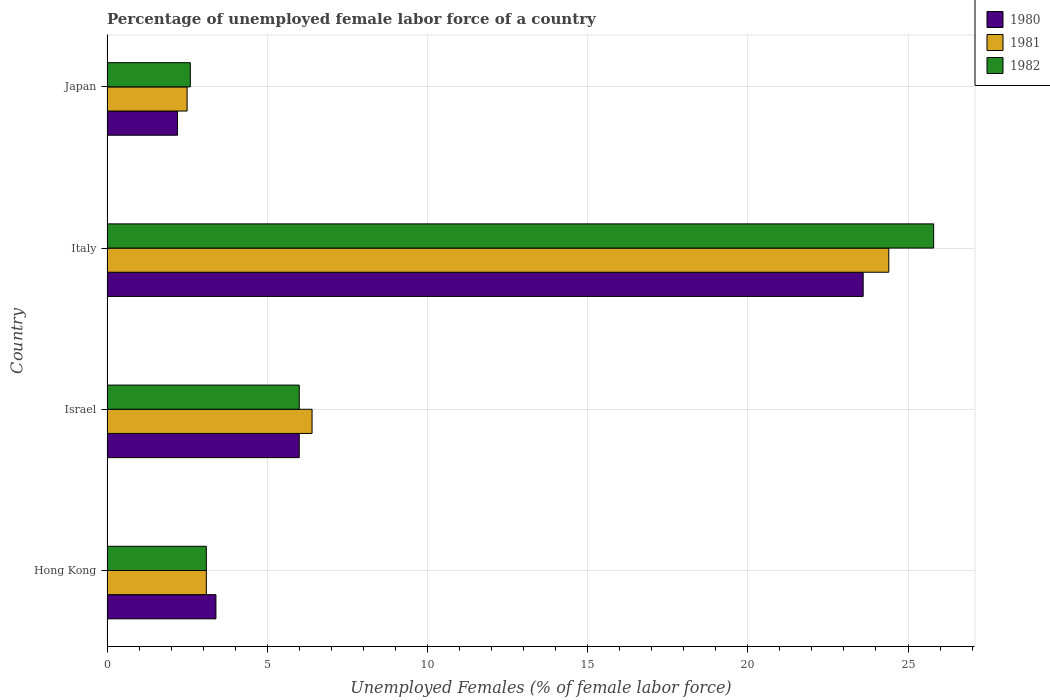How many different coloured bars are there?
Your answer should be very brief. 3. How many bars are there on the 1st tick from the top?
Provide a short and direct response. 3. What is the label of the 4th group of bars from the top?
Offer a very short reply. Hong Kong. What is the percentage of unemployed female labor force in 1982 in Japan?
Provide a short and direct response. 2.6. Across all countries, what is the maximum percentage of unemployed female labor force in 1982?
Your answer should be compact. 25.8. What is the total percentage of unemployed female labor force in 1981 in the graph?
Your answer should be very brief. 36.4. What is the difference between the percentage of unemployed female labor force in 1982 in Hong Kong and that in Italy?
Offer a terse response. -22.7. What is the difference between the percentage of unemployed female labor force in 1981 in Israel and the percentage of unemployed female labor force in 1980 in Japan?
Provide a short and direct response. 4.2. What is the average percentage of unemployed female labor force in 1980 per country?
Provide a succinct answer. 8.8. What is the difference between the percentage of unemployed female labor force in 1981 and percentage of unemployed female labor force in 1980 in Hong Kong?
Provide a succinct answer. -0.3. What is the ratio of the percentage of unemployed female labor force in 1981 in Hong Kong to that in Israel?
Keep it short and to the point. 0.48. What is the difference between the highest and the second highest percentage of unemployed female labor force in 1982?
Your answer should be compact. 19.8. What is the difference between the highest and the lowest percentage of unemployed female labor force in 1980?
Keep it short and to the point. 21.4. Is the sum of the percentage of unemployed female labor force in 1980 in Israel and Italy greater than the maximum percentage of unemployed female labor force in 1982 across all countries?
Give a very brief answer. Yes. What does the 3rd bar from the top in Hong Kong represents?
Provide a succinct answer. 1980. Is it the case that in every country, the sum of the percentage of unemployed female labor force in 1981 and percentage of unemployed female labor force in 1982 is greater than the percentage of unemployed female labor force in 1980?
Provide a succinct answer. Yes. How many bars are there?
Offer a very short reply. 12. How many countries are there in the graph?
Provide a short and direct response. 4. Does the graph contain any zero values?
Make the answer very short. No. Does the graph contain grids?
Provide a short and direct response. Yes. How are the legend labels stacked?
Your answer should be very brief. Vertical. What is the title of the graph?
Give a very brief answer. Percentage of unemployed female labor force of a country. Does "1998" appear as one of the legend labels in the graph?
Offer a terse response. No. What is the label or title of the X-axis?
Ensure brevity in your answer.  Unemployed Females (% of female labor force). What is the Unemployed Females (% of female labor force) in 1980 in Hong Kong?
Give a very brief answer. 3.4. What is the Unemployed Females (% of female labor force) of 1981 in Hong Kong?
Keep it short and to the point. 3.1. What is the Unemployed Females (% of female labor force) of 1982 in Hong Kong?
Your answer should be very brief. 3.1. What is the Unemployed Females (% of female labor force) of 1980 in Israel?
Your answer should be compact. 6. What is the Unemployed Females (% of female labor force) in 1981 in Israel?
Provide a succinct answer. 6.4. What is the Unemployed Females (% of female labor force) of 1980 in Italy?
Provide a short and direct response. 23.6. What is the Unemployed Females (% of female labor force) of 1981 in Italy?
Offer a terse response. 24.4. What is the Unemployed Females (% of female labor force) of 1982 in Italy?
Keep it short and to the point. 25.8. What is the Unemployed Females (% of female labor force) of 1980 in Japan?
Offer a terse response. 2.2. What is the Unemployed Females (% of female labor force) of 1982 in Japan?
Offer a terse response. 2.6. Across all countries, what is the maximum Unemployed Females (% of female labor force) of 1980?
Ensure brevity in your answer.  23.6. Across all countries, what is the maximum Unemployed Females (% of female labor force) of 1981?
Keep it short and to the point. 24.4. Across all countries, what is the maximum Unemployed Females (% of female labor force) of 1982?
Provide a short and direct response. 25.8. Across all countries, what is the minimum Unemployed Females (% of female labor force) in 1980?
Make the answer very short. 2.2. Across all countries, what is the minimum Unemployed Females (% of female labor force) in 1982?
Offer a very short reply. 2.6. What is the total Unemployed Females (% of female labor force) in 1980 in the graph?
Your answer should be very brief. 35.2. What is the total Unemployed Females (% of female labor force) of 1981 in the graph?
Provide a succinct answer. 36.4. What is the total Unemployed Females (% of female labor force) in 1982 in the graph?
Provide a short and direct response. 37.5. What is the difference between the Unemployed Females (% of female labor force) in 1980 in Hong Kong and that in Israel?
Give a very brief answer. -2.6. What is the difference between the Unemployed Females (% of female labor force) of 1982 in Hong Kong and that in Israel?
Your answer should be compact. -2.9. What is the difference between the Unemployed Females (% of female labor force) of 1980 in Hong Kong and that in Italy?
Provide a succinct answer. -20.2. What is the difference between the Unemployed Females (% of female labor force) of 1981 in Hong Kong and that in Italy?
Provide a succinct answer. -21.3. What is the difference between the Unemployed Females (% of female labor force) in 1982 in Hong Kong and that in Italy?
Ensure brevity in your answer.  -22.7. What is the difference between the Unemployed Females (% of female labor force) of 1980 in Israel and that in Italy?
Keep it short and to the point. -17.6. What is the difference between the Unemployed Females (% of female labor force) of 1982 in Israel and that in Italy?
Offer a very short reply. -19.8. What is the difference between the Unemployed Females (% of female labor force) in 1980 in Israel and that in Japan?
Offer a very short reply. 3.8. What is the difference between the Unemployed Females (% of female labor force) of 1980 in Italy and that in Japan?
Provide a succinct answer. 21.4. What is the difference between the Unemployed Females (% of female labor force) in 1981 in Italy and that in Japan?
Ensure brevity in your answer.  21.9. What is the difference between the Unemployed Females (% of female labor force) in 1982 in Italy and that in Japan?
Provide a short and direct response. 23.2. What is the difference between the Unemployed Females (% of female labor force) of 1980 in Hong Kong and the Unemployed Females (% of female labor force) of 1981 in Israel?
Your answer should be very brief. -3. What is the difference between the Unemployed Females (% of female labor force) of 1980 in Hong Kong and the Unemployed Females (% of female labor force) of 1982 in Israel?
Make the answer very short. -2.6. What is the difference between the Unemployed Females (% of female labor force) in 1980 in Hong Kong and the Unemployed Females (% of female labor force) in 1982 in Italy?
Make the answer very short. -22.4. What is the difference between the Unemployed Females (% of female labor force) in 1981 in Hong Kong and the Unemployed Females (% of female labor force) in 1982 in Italy?
Offer a terse response. -22.7. What is the difference between the Unemployed Females (% of female labor force) of 1980 in Hong Kong and the Unemployed Females (% of female labor force) of 1981 in Japan?
Your response must be concise. 0.9. What is the difference between the Unemployed Females (% of female labor force) in 1980 in Hong Kong and the Unemployed Females (% of female labor force) in 1982 in Japan?
Make the answer very short. 0.8. What is the difference between the Unemployed Females (% of female labor force) in 1981 in Hong Kong and the Unemployed Females (% of female labor force) in 1982 in Japan?
Offer a very short reply. 0.5. What is the difference between the Unemployed Females (% of female labor force) of 1980 in Israel and the Unemployed Females (% of female labor force) of 1981 in Italy?
Your answer should be compact. -18.4. What is the difference between the Unemployed Females (% of female labor force) of 1980 in Israel and the Unemployed Females (% of female labor force) of 1982 in Italy?
Make the answer very short. -19.8. What is the difference between the Unemployed Females (% of female labor force) of 1981 in Israel and the Unemployed Females (% of female labor force) of 1982 in Italy?
Ensure brevity in your answer.  -19.4. What is the difference between the Unemployed Females (% of female labor force) in 1981 in Israel and the Unemployed Females (% of female labor force) in 1982 in Japan?
Offer a terse response. 3.8. What is the difference between the Unemployed Females (% of female labor force) in 1980 in Italy and the Unemployed Females (% of female labor force) in 1981 in Japan?
Your response must be concise. 21.1. What is the difference between the Unemployed Females (% of female labor force) in 1980 in Italy and the Unemployed Females (% of female labor force) in 1982 in Japan?
Provide a succinct answer. 21. What is the difference between the Unemployed Females (% of female labor force) in 1981 in Italy and the Unemployed Females (% of female labor force) in 1982 in Japan?
Keep it short and to the point. 21.8. What is the average Unemployed Females (% of female labor force) of 1981 per country?
Your answer should be very brief. 9.1. What is the average Unemployed Females (% of female labor force) in 1982 per country?
Your answer should be compact. 9.38. What is the difference between the Unemployed Females (% of female labor force) in 1980 and Unemployed Females (% of female labor force) in 1981 in Israel?
Make the answer very short. -0.4. What is the difference between the Unemployed Females (% of female labor force) of 1980 and Unemployed Females (% of female labor force) of 1982 in Israel?
Provide a succinct answer. 0. What is the difference between the Unemployed Females (% of female labor force) in 1980 and Unemployed Females (% of female labor force) in 1982 in Italy?
Give a very brief answer. -2.2. What is the difference between the Unemployed Females (% of female labor force) in 1981 and Unemployed Females (% of female labor force) in 1982 in Italy?
Offer a very short reply. -1.4. What is the difference between the Unemployed Females (% of female labor force) in 1980 and Unemployed Females (% of female labor force) in 1981 in Japan?
Keep it short and to the point. -0.3. What is the difference between the Unemployed Females (% of female labor force) in 1980 and Unemployed Females (% of female labor force) in 1982 in Japan?
Make the answer very short. -0.4. What is the difference between the Unemployed Females (% of female labor force) of 1981 and Unemployed Females (% of female labor force) of 1982 in Japan?
Make the answer very short. -0.1. What is the ratio of the Unemployed Females (% of female labor force) of 1980 in Hong Kong to that in Israel?
Keep it short and to the point. 0.57. What is the ratio of the Unemployed Females (% of female labor force) in 1981 in Hong Kong to that in Israel?
Make the answer very short. 0.48. What is the ratio of the Unemployed Females (% of female labor force) in 1982 in Hong Kong to that in Israel?
Make the answer very short. 0.52. What is the ratio of the Unemployed Females (% of female labor force) of 1980 in Hong Kong to that in Italy?
Offer a terse response. 0.14. What is the ratio of the Unemployed Females (% of female labor force) of 1981 in Hong Kong to that in Italy?
Your answer should be very brief. 0.13. What is the ratio of the Unemployed Females (% of female labor force) of 1982 in Hong Kong to that in Italy?
Keep it short and to the point. 0.12. What is the ratio of the Unemployed Females (% of female labor force) of 1980 in Hong Kong to that in Japan?
Your answer should be compact. 1.55. What is the ratio of the Unemployed Females (% of female labor force) in 1981 in Hong Kong to that in Japan?
Offer a terse response. 1.24. What is the ratio of the Unemployed Females (% of female labor force) in 1982 in Hong Kong to that in Japan?
Give a very brief answer. 1.19. What is the ratio of the Unemployed Females (% of female labor force) in 1980 in Israel to that in Italy?
Your response must be concise. 0.25. What is the ratio of the Unemployed Females (% of female labor force) of 1981 in Israel to that in Italy?
Your answer should be very brief. 0.26. What is the ratio of the Unemployed Females (% of female labor force) in 1982 in Israel to that in Italy?
Give a very brief answer. 0.23. What is the ratio of the Unemployed Females (% of female labor force) of 1980 in Israel to that in Japan?
Offer a terse response. 2.73. What is the ratio of the Unemployed Females (% of female labor force) in 1981 in Israel to that in Japan?
Provide a succinct answer. 2.56. What is the ratio of the Unemployed Females (% of female labor force) in 1982 in Israel to that in Japan?
Your answer should be compact. 2.31. What is the ratio of the Unemployed Females (% of female labor force) in 1980 in Italy to that in Japan?
Provide a short and direct response. 10.73. What is the ratio of the Unemployed Females (% of female labor force) in 1981 in Italy to that in Japan?
Provide a succinct answer. 9.76. What is the ratio of the Unemployed Females (% of female labor force) in 1982 in Italy to that in Japan?
Ensure brevity in your answer.  9.92. What is the difference between the highest and the second highest Unemployed Females (% of female labor force) in 1981?
Give a very brief answer. 18. What is the difference between the highest and the second highest Unemployed Females (% of female labor force) of 1982?
Ensure brevity in your answer.  19.8. What is the difference between the highest and the lowest Unemployed Females (% of female labor force) of 1980?
Your answer should be very brief. 21.4. What is the difference between the highest and the lowest Unemployed Females (% of female labor force) of 1981?
Your response must be concise. 21.9. What is the difference between the highest and the lowest Unemployed Females (% of female labor force) in 1982?
Provide a succinct answer. 23.2. 